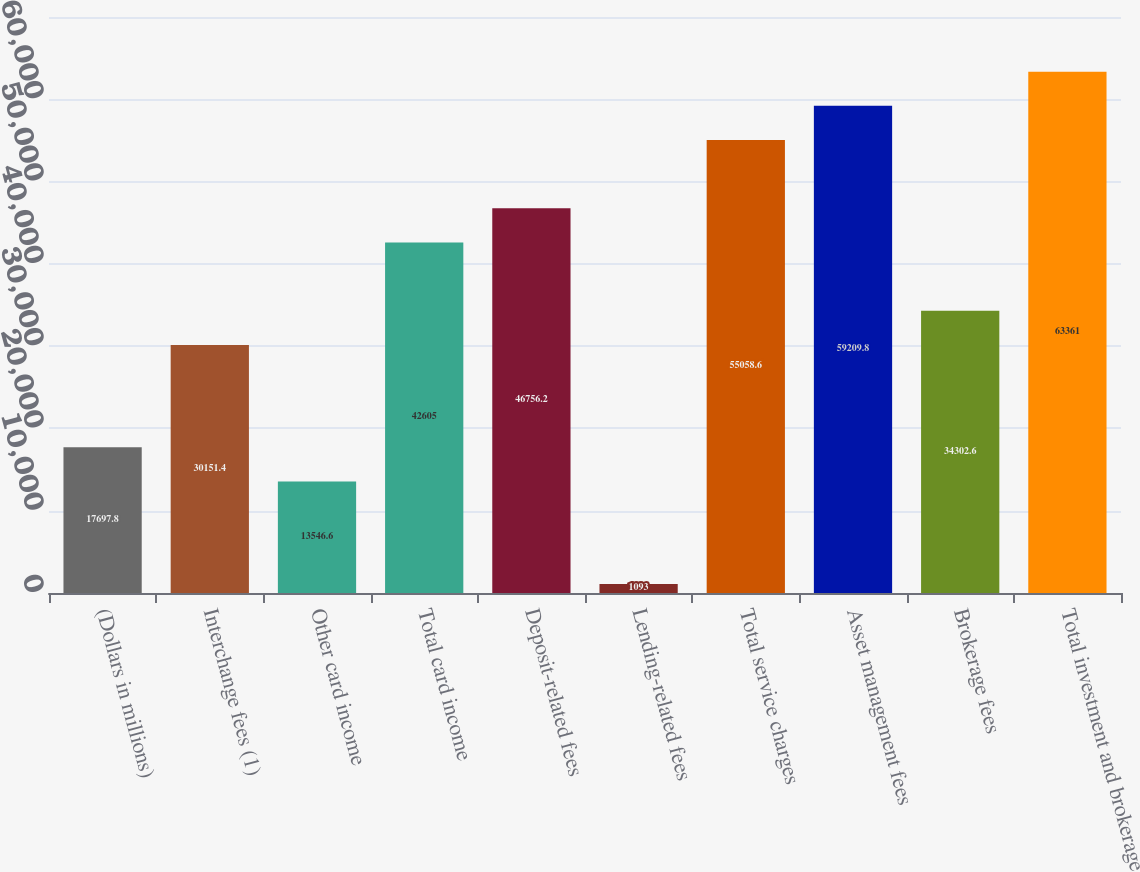Convert chart. <chart><loc_0><loc_0><loc_500><loc_500><bar_chart><fcel>(Dollars in millions)<fcel>Interchange fees (1)<fcel>Other card income<fcel>Total card income<fcel>Deposit-related fees<fcel>Lending-related fees<fcel>Total service charges<fcel>Asset management fees<fcel>Brokerage fees<fcel>Total investment and brokerage<nl><fcel>17697.8<fcel>30151.4<fcel>13546.6<fcel>42605<fcel>46756.2<fcel>1093<fcel>55058.6<fcel>59209.8<fcel>34302.6<fcel>63361<nl></chart> 